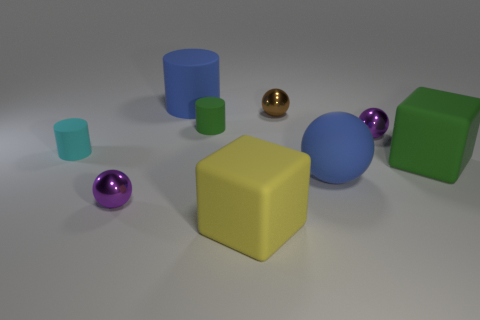What might be the context or setting of this collection of objects? This collection of objects could be part of a 3D rendering or modeling practice scene. The diverse shapes and colors are deliberately chosen to demonstrate rendering capabilities, such as reflections, textures, and lighting. It's a controlled environment that might be used for educational purposes or to test graphic rendering software. 